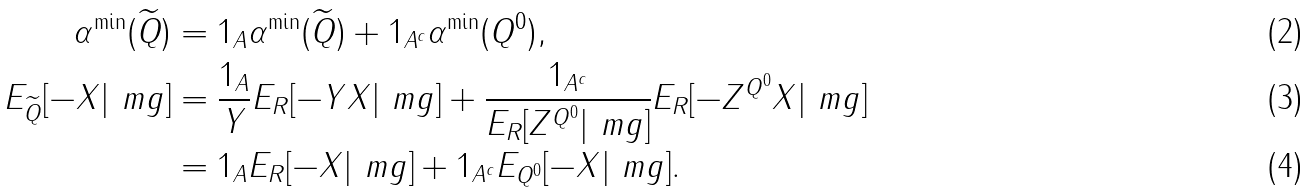<formula> <loc_0><loc_0><loc_500><loc_500>\alpha ^ { \min } ( \widetilde { Q } ) & = 1 _ { A } \alpha ^ { \min } ( \widetilde { Q } ) + 1 _ { A ^ { c } } \alpha ^ { \min } ( Q ^ { 0 } ) , \\ E _ { \widetilde { Q } } [ - X | \ m g ] & = \frac { 1 _ { A } } { Y } E _ { R } [ - Y X | \ m g ] + \frac { 1 _ { A ^ { c } } } { E _ { R } [ Z ^ { Q ^ { 0 } } | \ m g ] } E _ { R } [ - Z ^ { Q ^ { 0 } } X | \ m g ] \\ & = 1 _ { A } E _ { R } [ - X | \ m g ] + 1 _ { A ^ { c } } E _ { Q ^ { 0 } } [ - X | \ m g ] .</formula> 